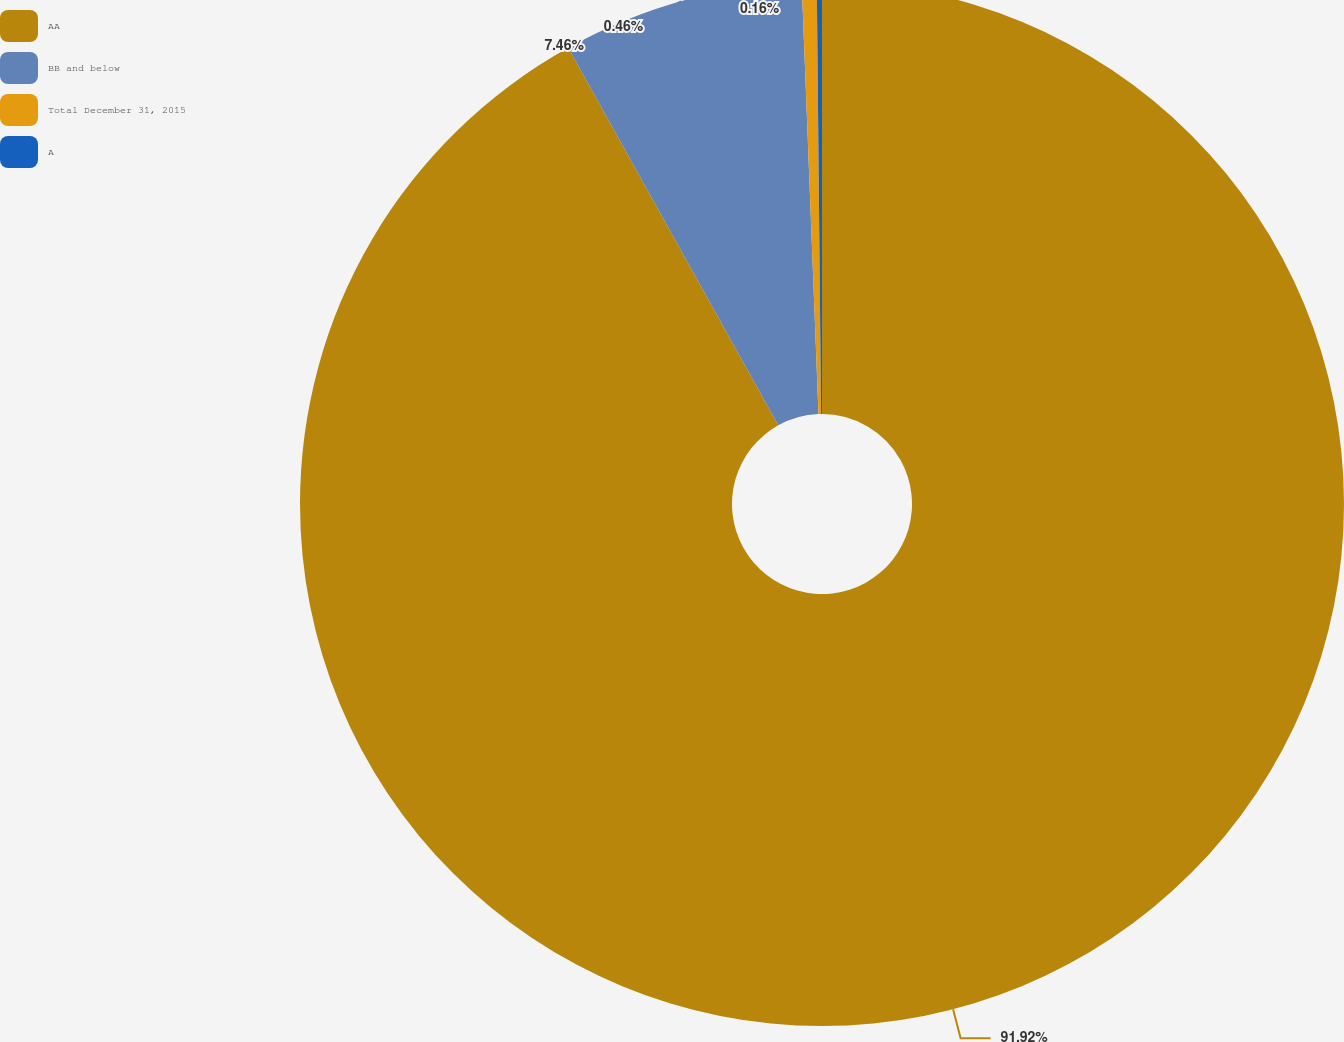Convert chart. <chart><loc_0><loc_0><loc_500><loc_500><pie_chart><fcel>AA<fcel>BB and below<fcel>Total December 31, 2015<fcel>A<nl><fcel>91.92%<fcel>7.46%<fcel>0.46%<fcel>0.16%<nl></chart> 